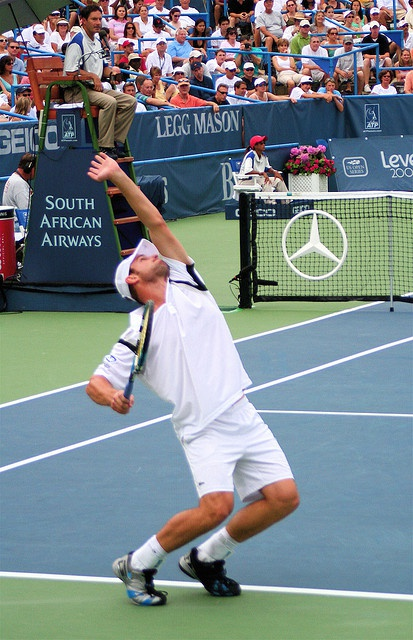Describe the objects in this image and their specific colors. I can see people in black, lavender, brown, and darkgray tones, people in black, lavender, brown, and maroon tones, people in black, gray, and lightgray tones, chair in black, maroon, and brown tones, and potted plant in black, lightgray, darkgray, and maroon tones in this image. 